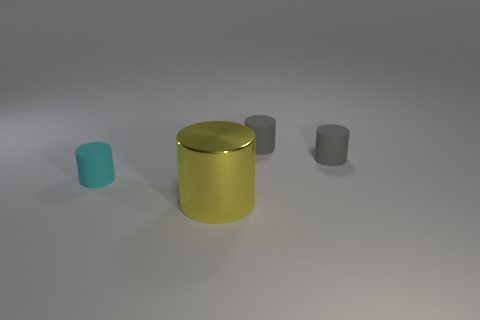Subtract all cyan cylinders. How many cylinders are left? 3 Subtract all yellow cylinders. How many cylinders are left? 3 Subtract all brown cylinders. Subtract all purple balls. How many cylinders are left? 4 Add 1 small gray matte cylinders. How many objects exist? 5 Subtract all large blue metallic cubes. Subtract all gray cylinders. How many objects are left? 2 Add 4 tiny cyan rubber things. How many tiny cyan rubber things are left? 5 Add 3 cyan matte cylinders. How many cyan matte cylinders exist? 4 Subtract 0 yellow balls. How many objects are left? 4 